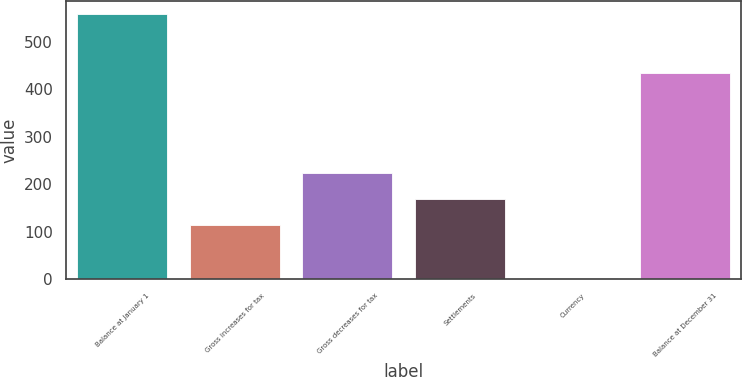Convert chart. <chart><loc_0><loc_0><loc_500><loc_500><bar_chart><fcel>Balance at January 1<fcel>Gross increases for tax<fcel>Gross decreases for tax<fcel>Settlements<fcel>Currency<fcel>Balance at December 31<nl><fcel>558<fcel>113.2<fcel>224.4<fcel>168.8<fcel>2<fcel>435<nl></chart> 